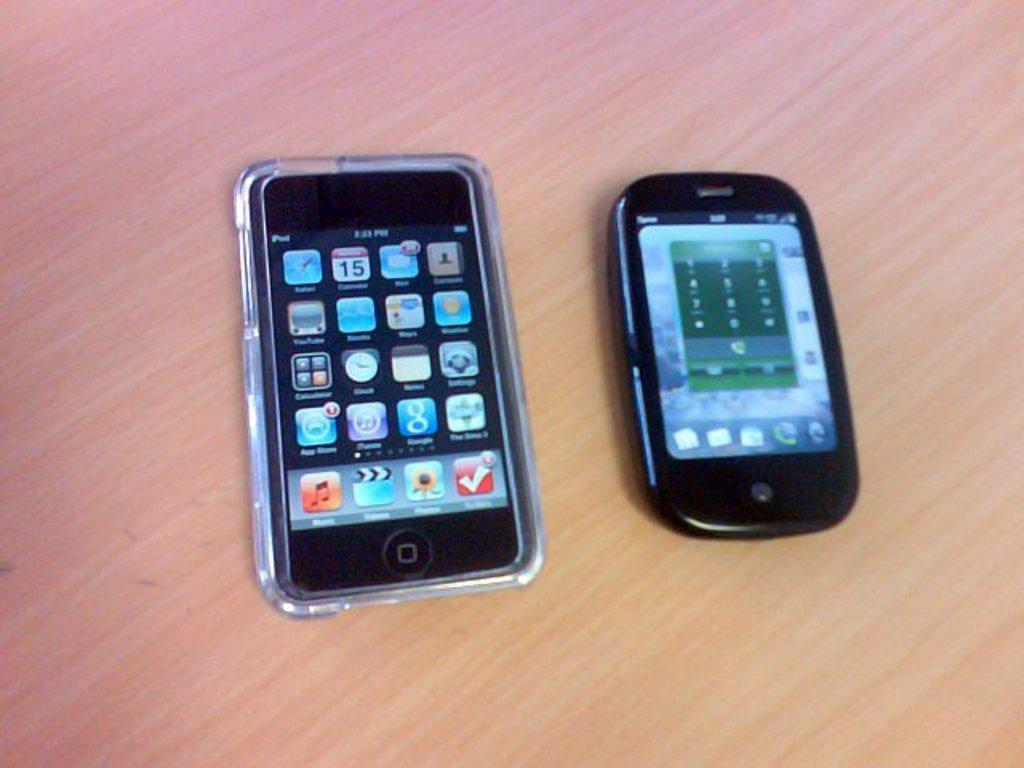<image>
Offer a succinct explanation of the picture presented. The cellphone on the left shows a date of 15 on the calendar app. 